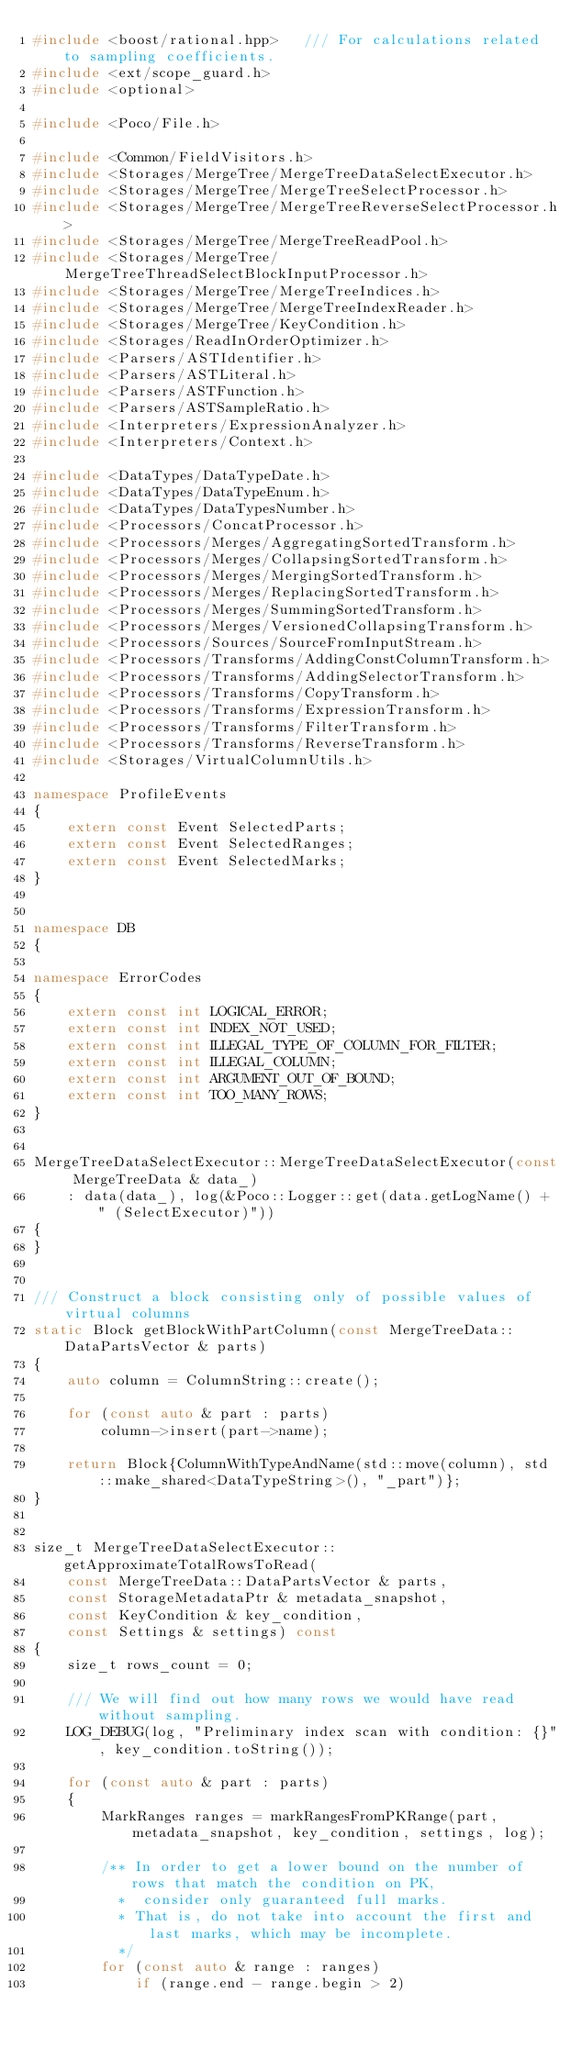Convert code to text. <code><loc_0><loc_0><loc_500><loc_500><_C++_>#include <boost/rational.hpp>   /// For calculations related to sampling coefficients.
#include <ext/scope_guard.h>
#include <optional>

#include <Poco/File.h>

#include <Common/FieldVisitors.h>
#include <Storages/MergeTree/MergeTreeDataSelectExecutor.h>
#include <Storages/MergeTree/MergeTreeSelectProcessor.h>
#include <Storages/MergeTree/MergeTreeReverseSelectProcessor.h>
#include <Storages/MergeTree/MergeTreeReadPool.h>
#include <Storages/MergeTree/MergeTreeThreadSelectBlockInputProcessor.h>
#include <Storages/MergeTree/MergeTreeIndices.h>
#include <Storages/MergeTree/MergeTreeIndexReader.h>
#include <Storages/MergeTree/KeyCondition.h>
#include <Storages/ReadInOrderOptimizer.h>
#include <Parsers/ASTIdentifier.h>
#include <Parsers/ASTLiteral.h>
#include <Parsers/ASTFunction.h>
#include <Parsers/ASTSampleRatio.h>
#include <Interpreters/ExpressionAnalyzer.h>
#include <Interpreters/Context.h>

#include <DataTypes/DataTypeDate.h>
#include <DataTypes/DataTypeEnum.h>
#include <DataTypes/DataTypesNumber.h>
#include <Processors/ConcatProcessor.h>
#include <Processors/Merges/AggregatingSortedTransform.h>
#include <Processors/Merges/CollapsingSortedTransform.h>
#include <Processors/Merges/MergingSortedTransform.h>
#include <Processors/Merges/ReplacingSortedTransform.h>
#include <Processors/Merges/SummingSortedTransform.h>
#include <Processors/Merges/VersionedCollapsingTransform.h>
#include <Processors/Sources/SourceFromInputStream.h>
#include <Processors/Transforms/AddingConstColumnTransform.h>
#include <Processors/Transforms/AddingSelectorTransform.h>
#include <Processors/Transforms/CopyTransform.h>
#include <Processors/Transforms/ExpressionTransform.h>
#include <Processors/Transforms/FilterTransform.h>
#include <Processors/Transforms/ReverseTransform.h>
#include <Storages/VirtualColumnUtils.h>

namespace ProfileEvents
{
    extern const Event SelectedParts;
    extern const Event SelectedRanges;
    extern const Event SelectedMarks;
}


namespace DB
{

namespace ErrorCodes
{
    extern const int LOGICAL_ERROR;
    extern const int INDEX_NOT_USED;
    extern const int ILLEGAL_TYPE_OF_COLUMN_FOR_FILTER;
    extern const int ILLEGAL_COLUMN;
    extern const int ARGUMENT_OUT_OF_BOUND;
    extern const int TOO_MANY_ROWS;
}


MergeTreeDataSelectExecutor::MergeTreeDataSelectExecutor(const MergeTreeData & data_)
    : data(data_), log(&Poco::Logger::get(data.getLogName() + " (SelectExecutor)"))
{
}


/// Construct a block consisting only of possible values of virtual columns
static Block getBlockWithPartColumn(const MergeTreeData::DataPartsVector & parts)
{
    auto column = ColumnString::create();

    for (const auto & part : parts)
        column->insert(part->name);

    return Block{ColumnWithTypeAndName(std::move(column), std::make_shared<DataTypeString>(), "_part")};
}


size_t MergeTreeDataSelectExecutor::getApproximateTotalRowsToRead(
    const MergeTreeData::DataPartsVector & parts,
    const StorageMetadataPtr & metadata_snapshot,
    const KeyCondition & key_condition,
    const Settings & settings) const
{
    size_t rows_count = 0;

    /// We will find out how many rows we would have read without sampling.
    LOG_DEBUG(log, "Preliminary index scan with condition: {}", key_condition.toString());

    for (const auto & part : parts)
    {
        MarkRanges ranges = markRangesFromPKRange(part, metadata_snapshot, key_condition, settings, log);

        /** In order to get a lower bound on the number of rows that match the condition on PK,
          *  consider only guaranteed full marks.
          * That is, do not take into account the first and last marks, which may be incomplete.
          */
        for (const auto & range : ranges)
            if (range.end - range.begin > 2)</code> 